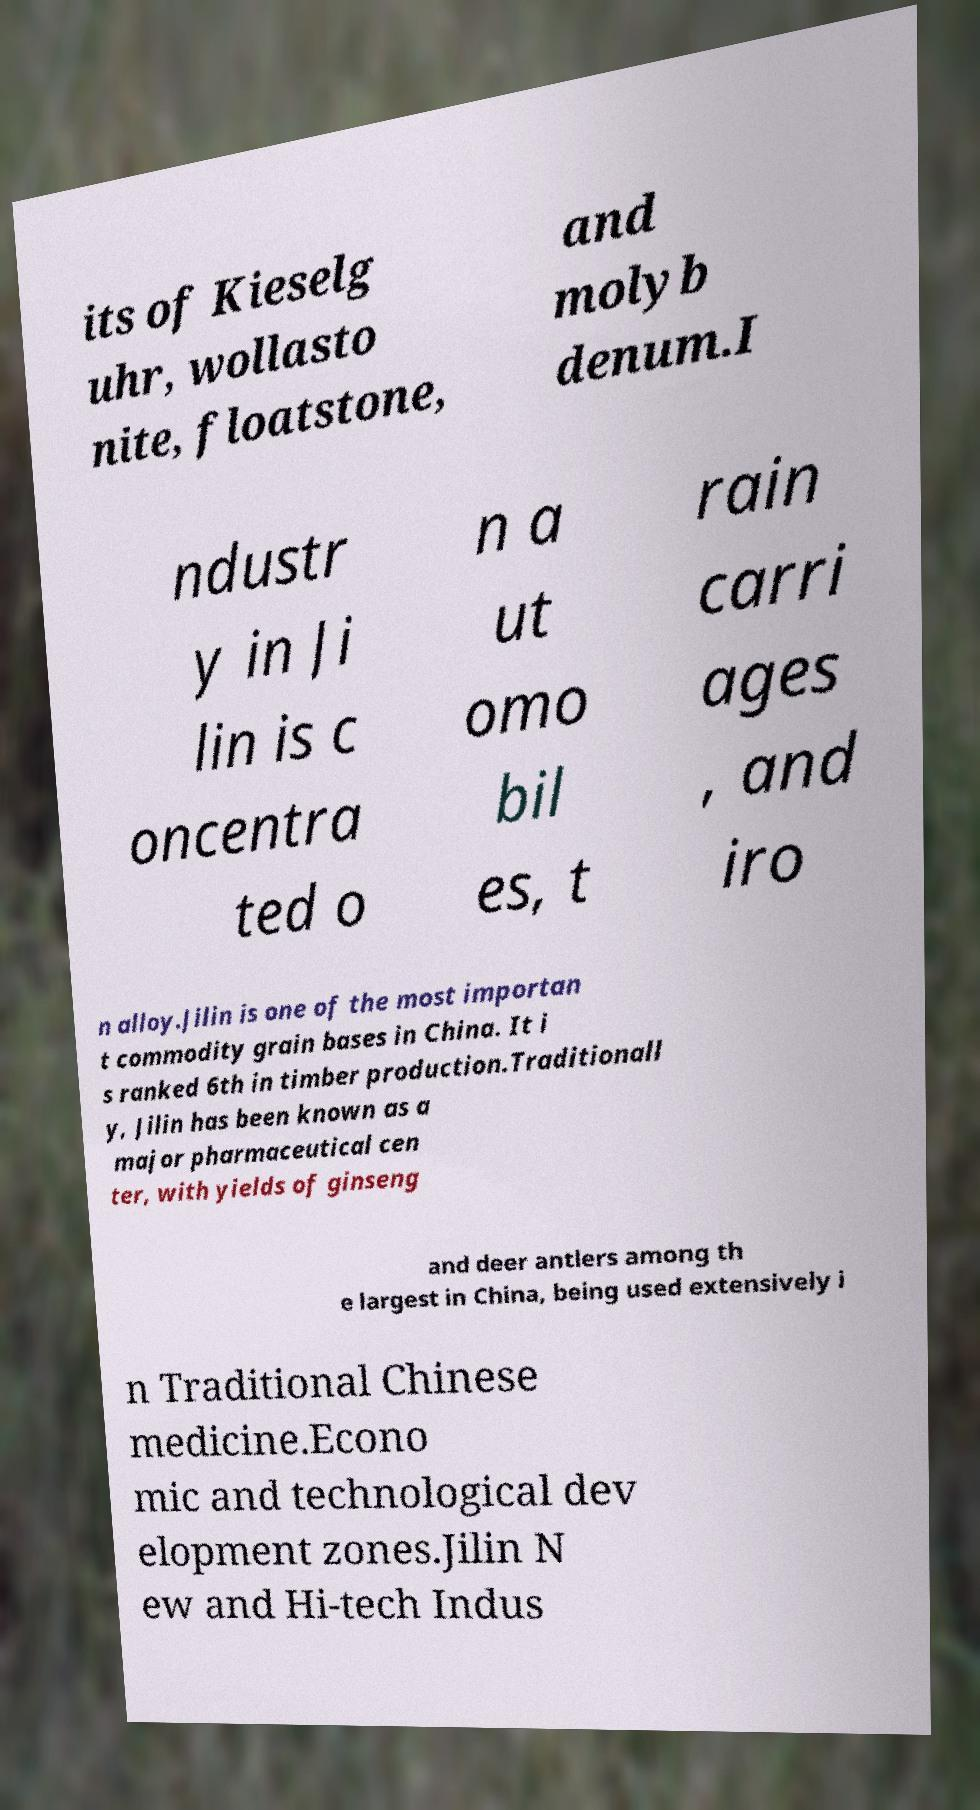What messages or text are displayed in this image? I need them in a readable, typed format. its of Kieselg uhr, wollasto nite, floatstone, and molyb denum.I ndustr y in Ji lin is c oncentra ted o n a ut omo bil es, t rain carri ages , and iro n alloy.Jilin is one of the most importan t commodity grain bases in China. It i s ranked 6th in timber production.Traditionall y, Jilin has been known as a major pharmaceutical cen ter, with yields of ginseng and deer antlers among th e largest in China, being used extensively i n Traditional Chinese medicine.Econo mic and technological dev elopment zones.Jilin N ew and Hi-tech Indus 